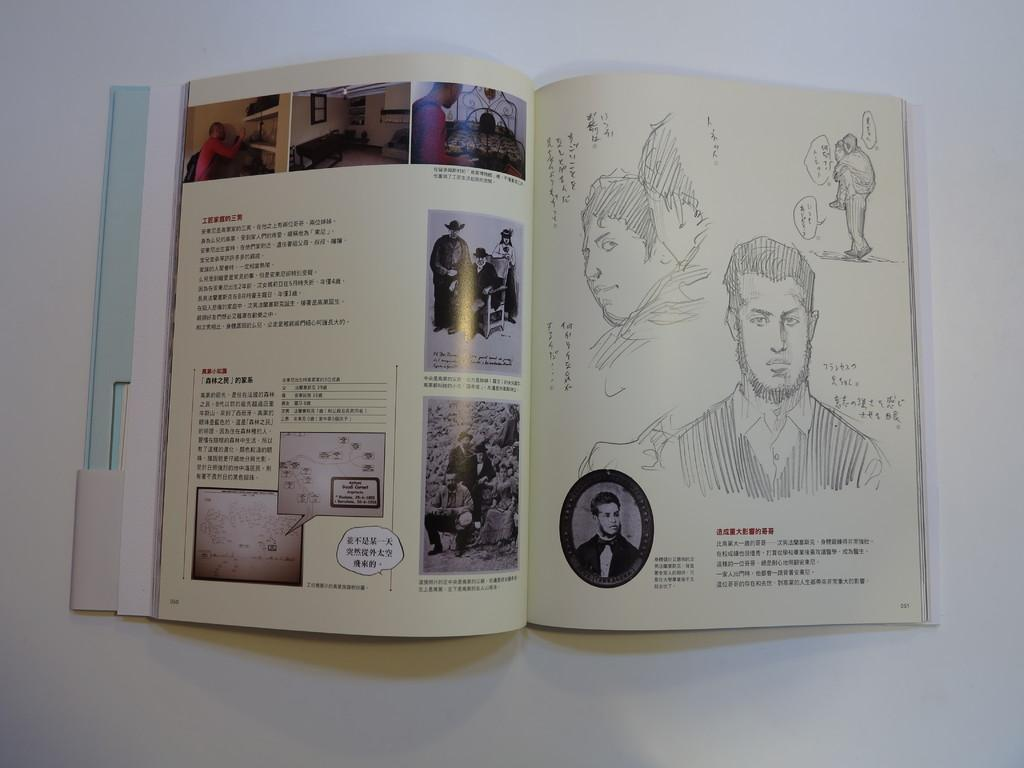What is the main object in the image? There is a book in the image. Where is the book located in the image? The book is in the center of the image. What color is the surface the book is resting on? The surface the book is on is white in color. What brand of toothpaste is shown next to the book in the image? There is no toothpaste present in the image; it only features a book on a white surface. 